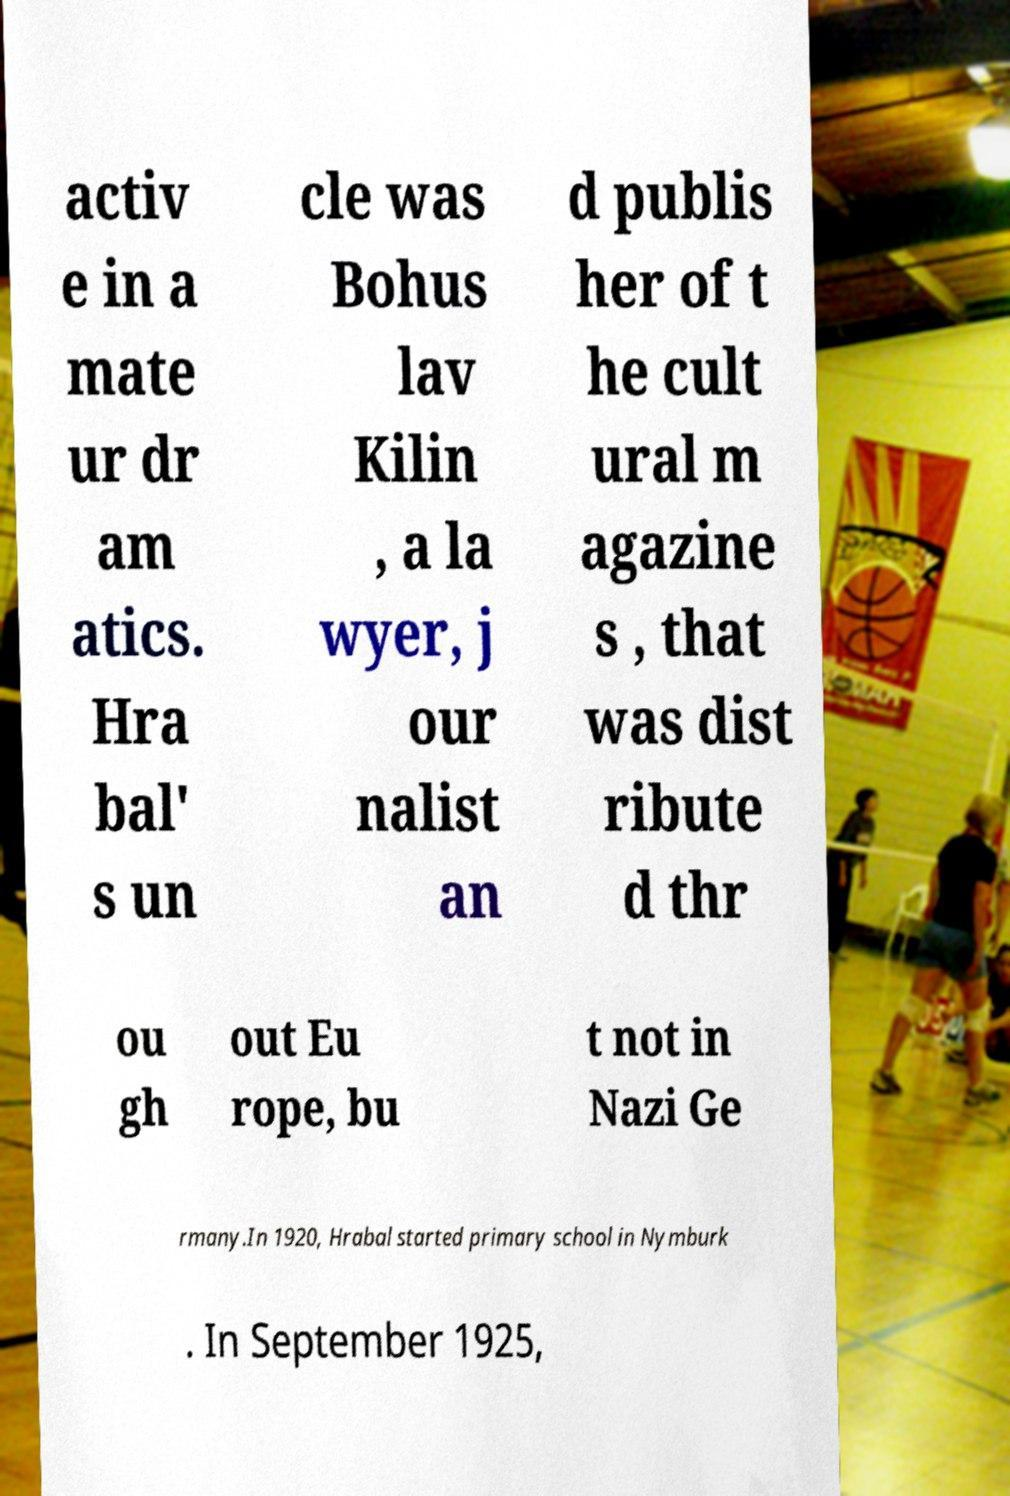Please read and relay the text visible in this image. What does it say? activ e in a mate ur dr am atics. Hra bal' s un cle was Bohus lav Kilin , a la wyer, j our nalist an d publis her of t he cult ural m agazine s , that was dist ribute d thr ou gh out Eu rope, bu t not in Nazi Ge rmany.In 1920, Hrabal started primary school in Nymburk . In September 1925, 